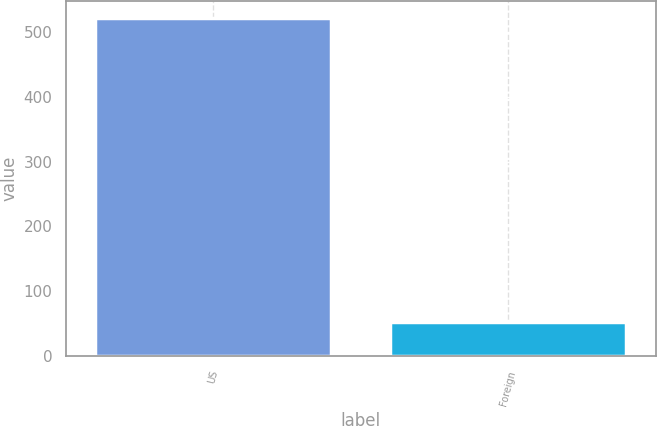Convert chart. <chart><loc_0><loc_0><loc_500><loc_500><bar_chart><fcel>US<fcel>Foreign<nl><fcel>521.5<fcel>52.7<nl></chart> 